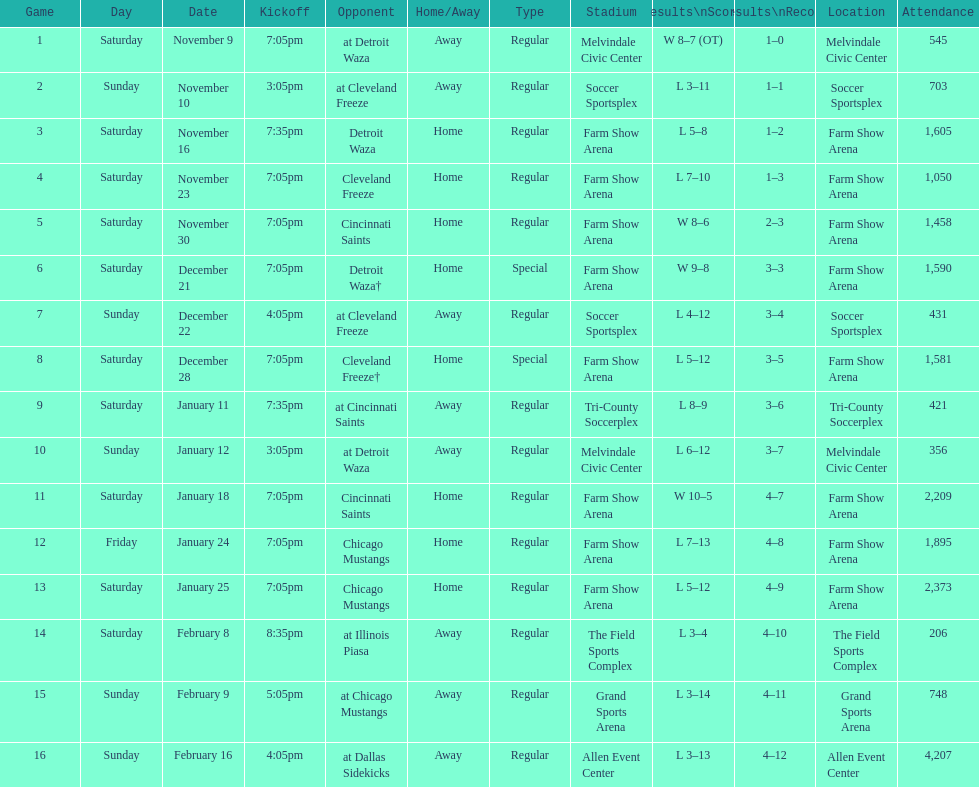Help me parse the entirety of this table. {'header': ['Game', 'Day', 'Date', 'Kickoff', 'Opponent', 'Home/Away', 'Type', 'Stadium', 'Results\\nScore', 'Results\\nRecord', 'Location', 'Attendance'], 'rows': [['1', 'Saturday', 'November 9', '7:05pm', 'at Detroit Waza', 'Away', 'Regular', 'Melvindale Civic Center', 'W 8–7 (OT)', '1–0', 'Melvindale Civic Center', '545'], ['2', 'Sunday', 'November 10', '3:05pm', 'at Cleveland Freeze', 'Away', 'Regular', 'Soccer Sportsplex', 'L 3–11', '1–1', 'Soccer Sportsplex', '703'], ['3', 'Saturday', 'November 16', '7:35pm', 'Detroit Waza', 'Home', 'Regular', 'Farm Show Arena', 'L 5–8', '1–2', 'Farm Show Arena', '1,605'], ['4', 'Saturday', 'November 23', '7:05pm', 'Cleveland Freeze', 'Home', 'Regular', 'Farm Show Arena', 'L 7–10', '1–3', 'Farm Show Arena', '1,050'], ['5', 'Saturday', 'November 30', '7:05pm', 'Cincinnati Saints', 'Home', 'Regular', 'Farm Show Arena', 'W 8–6', '2–3', 'Farm Show Arena', '1,458'], ['6', 'Saturday', 'December 21', '7:05pm', 'Detroit Waza†', 'Home', 'Special', 'Farm Show Arena', 'W 9–8', '3–3', 'Farm Show Arena', '1,590'], ['7', 'Sunday', 'December 22', '4:05pm', 'at Cleveland Freeze', 'Away', 'Regular', 'Soccer Sportsplex', 'L 4–12', '3–4', 'Soccer Sportsplex', '431'], ['8', 'Saturday', 'December 28', '7:05pm', 'Cleveland Freeze†', 'Home', 'Special', 'Farm Show Arena', 'L 5–12', '3–5', 'Farm Show Arena', '1,581'], ['9', 'Saturday', 'January 11', '7:35pm', 'at Cincinnati Saints', 'Away', 'Regular', 'Tri-County Soccerplex', 'L 8–9', '3–6', 'Tri-County Soccerplex', '421'], ['10', 'Sunday', 'January 12', '3:05pm', 'at Detroit Waza', 'Away', 'Regular', 'Melvindale Civic Center', 'L 6–12', '3–7', 'Melvindale Civic Center', '356'], ['11', 'Saturday', 'January 18', '7:05pm', 'Cincinnati Saints', 'Home', 'Regular', 'Farm Show Arena', 'W 10–5', '4–7', 'Farm Show Arena', '2,209'], ['12', 'Friday', 'January 24', '7:05pm', 'Chicago Mustangs', 'Home', 'Regular', 'Farm Show Arena', 'L 7–13', '4–8', 'Farm Show Arena', '1,895'], ['13', 'Saturday', 'January 25', '7:05pm', 'Chicago Mustangs', 'Home', 'Regular', 'Farm Show Arena', 'L 5–12', '4–9', 'Farm Show Arena', '2,373'], ['14', 'Saturday', 'February 8', '8:35pm', 'at Illinois Piasa', 'Away', 'Regular', 'The Field Sports Complex', 'L 3–4', '4–10', 'The Field Sports Complex', '206'], ['15', 'Sunday', 'February 9', '5:05pm', 'at Chicago Mustangs', 'Away', 'Regular', 'Grand Sports Arena', 'L 3–14', '4–11', 'Grand Sports Arena', '748'], ['16', 'Sunday', 'February 16', '4:05pm', 'at Dallas Sidekicks', 'Away', 'Regular', 'Allen Event Center', 'L 3–13', '4–12', 'Allen Event Center', '4,207']]} How many games did the harrisburg heat win in which they scored eight or more goals? 4. 